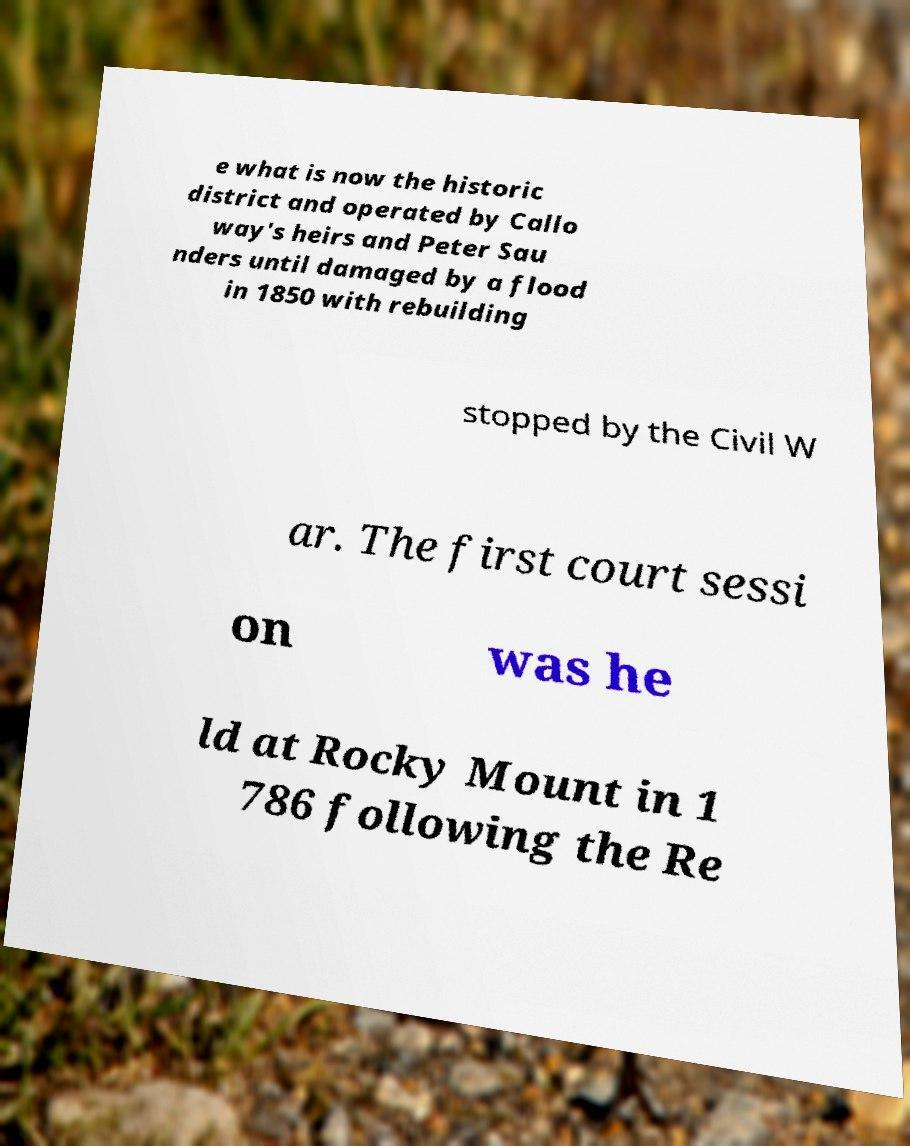For documentation purposes, I need the text within this image transcribed. Could you provide that? e what is now the historic district and operated by Callo way's heirs and Peter Sau nders until damaged by a flood in 1850 with rebuilding stopped by the Civil W ar. The first court sessi on was he ld at Rocky Mount in 1 786 following the Re 